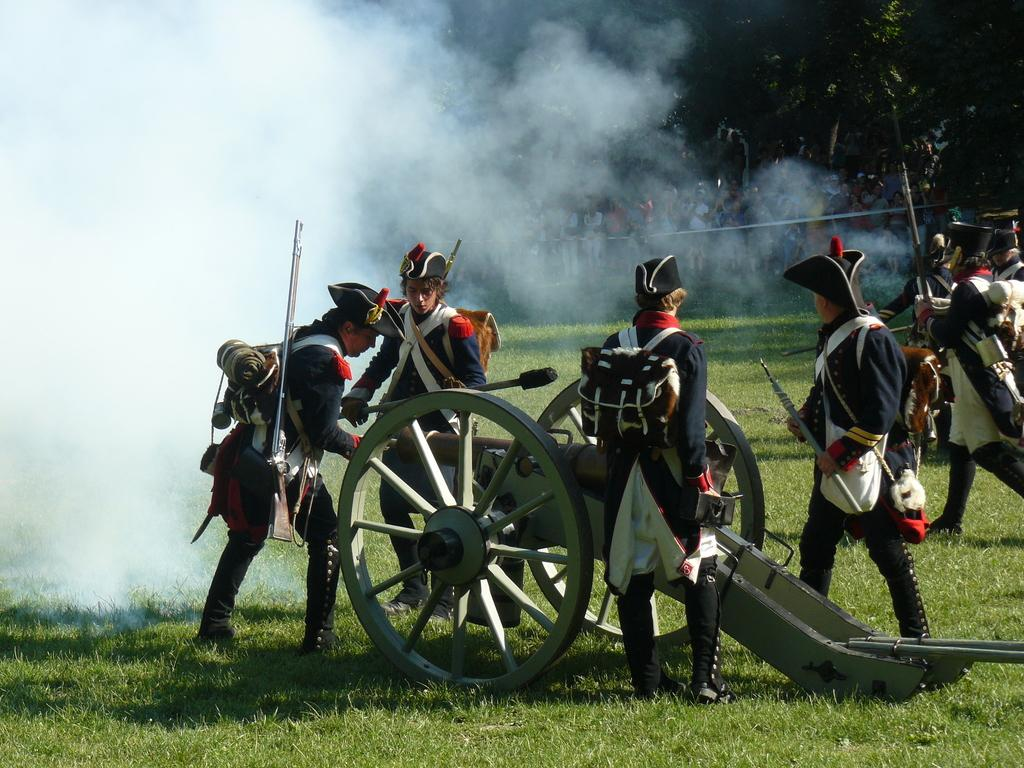How many people are present in the image? There are many people in the image. What are some of the people doing in the image? Some people are holding a vehicle and objects. What do the people in the image have in common? All the people are wearing the same colorful costume. What type of sugar can be seen in the image? There is no sugar present in the image. What kind of toys are the people playing with in the image? There are no toys visible in the image. 